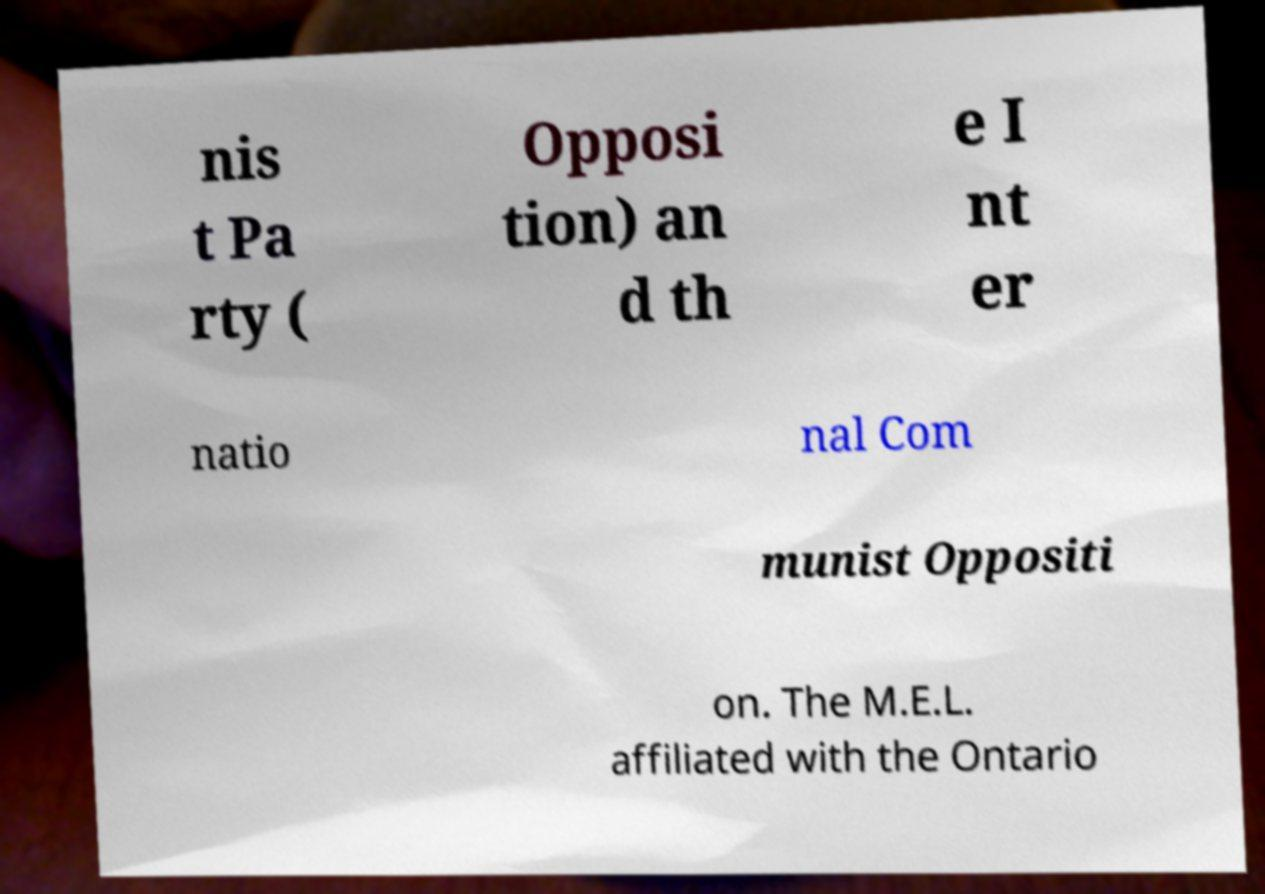I need the written content from this picture converted into text. Can you do that? nis t Pa rty ( Opposi tion) an d th e I nt er natio nal Com munist Oppositi on. The M.E.L. affiliated with the Ontario 